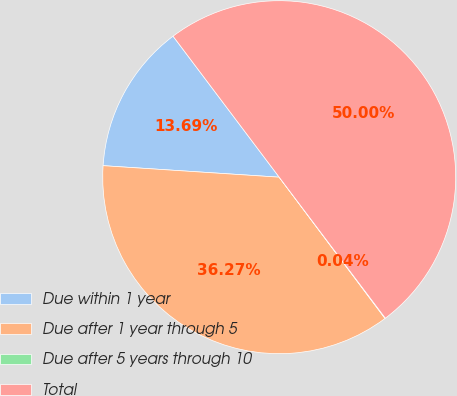<chart> <loc_0><loc_0><loc_500><loc_500><pie_chart><fcel>Due within 1 year<fcel>Due after 1 year through 5<fcel>Due after 5 years through 10<fcel>Total<nl><fcel>13.69%<fcel>36.27%<fcel>0.04%<fcel>50.0%<nl></chart> 